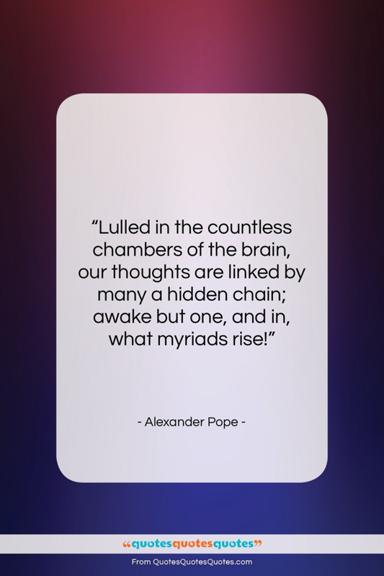Could the image composition be interpreted symbolically in relation to the quote? Indeed, the composition can be seen as symbolic. The central positioning of the quote can represent the 'one' awakened thought, with the surrounding gradient perhaps symbolizing the myriad thoughts that rise in response—just as the colors blend seamlessly into one another, so do our thoughts interconnect in the 'countless chambers of the brain.' The quote's isolation on the white card might signify the clarity that comes with focusing on a single thought amidst the potential chaos of the mind. 